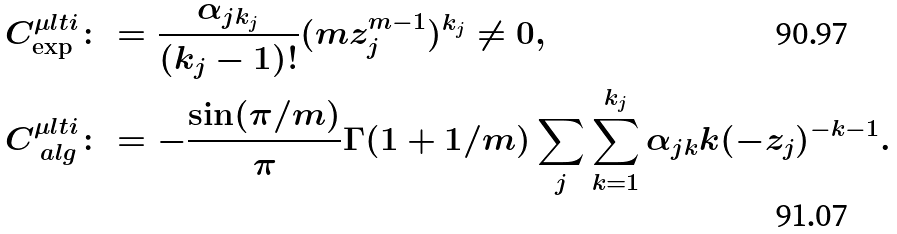<formula> <loc_0><loc_0><loc_500><loc_500>C _ { \exp } ^ { \mu l t i } & \colon = \frac { \alpha _ { j k _ { j } } } { ( k _ { j } - 1 ) ! } ( m z _ { j } ^ { m - 1 } ) ^ { k _ { j } } \neq 0 , \\ C _ { \ a l g } ^ { \mu l t i } & \colon = - \frac { \sin ( \pi / m ) } { \pi } \Gamma ( 1 + 1 / m ) \sum _ { j } \sum _ { k = 1 } ^ { k _ { j } } \alpha _ { j k } k ( - z _ { j } ) ^ { - k - 1 } .</formula> 